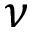Convert formula to latex. <formula><loc_0><loc_0><loc_500><loc_500>\nu</formula> 